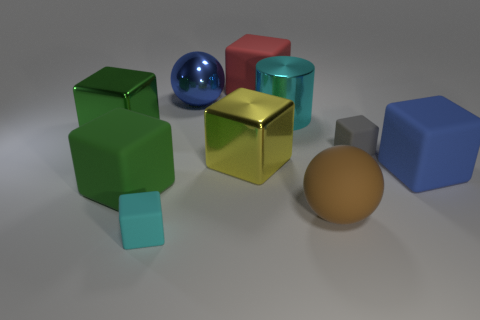Subtract all cyan blocks. How many blocks are left? 6 Subtract all metallic blocks. How many blocks are left? 5 Subtract all green cubes. Subtract all red cylinders. How many cubes are left? 5 Subtract all cylinders. How many objects are left? 9 Subtract 0 yellow cylinders. How many objects are left? 10 Subtract all large brown objects. Subtract all metal balls. How many objects are left? 8 Add 1 metal things. How many metal things are left? 5 Add 4 small cyan cylinders. How many small cyan cylinders exist? 4 